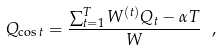<formula> <loc_0><loc_0><loc_500><loc_500>Q _ { \cos t } = \frac { \sum _ { t = 1 } ^ { T } W ^ { ( t ) } Q _ { t } - \alpha T } { W } \ ,</formula> 